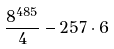Convert formula to latex. <formula><loc_0><loc_0><loc_500><loc_500>\frac { 8 ^ { 4 8 5 } } { 4 } - 2 5 7 \cdot 6</formula> 